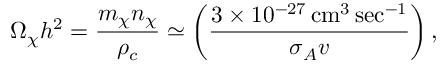Convert formula to latex. <formula><loc_0><loc_0><loc_500><loc_500>\Omega _ { \chi } h ^ { 2 } = { \frac { m _ { \chi } n _ { \chi } } { \rho _ { c } } } \simeq \left ( { \frac { 3 \times 1 0 ^ { - 2 7 } \, c m ^ { 3 } \, s e c ^ { - 1 } } { \sigma _ { A } v } } \right ) ,</formula> 